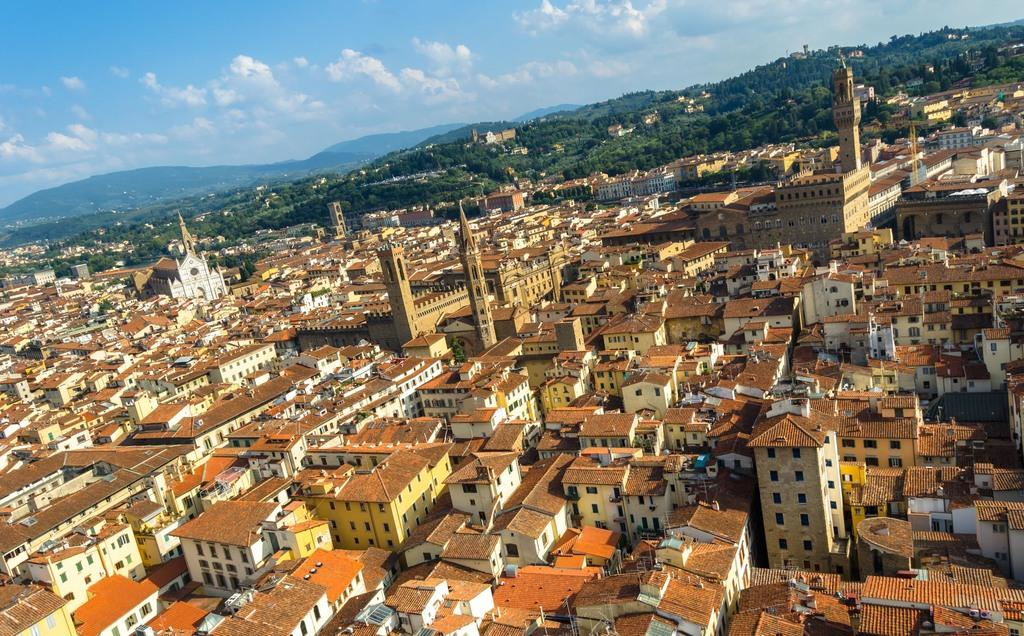What type of structures can be seen in the image? There are buildings in the image. What other natural elements are present in the image? There are trees in the image. Can you describe the landscape feature in the image? There is a hill visible in the image. How would you describe the sky in the image? The sky is blue and cloudy in the image. What type of competition is taking place on the hill in the image? There is no competition present in the image; it only shows buildings, trees, a hill, and a blue and cloudy sky. Can you tell me how much butter is being used in the image? There is no butter present in the image. 